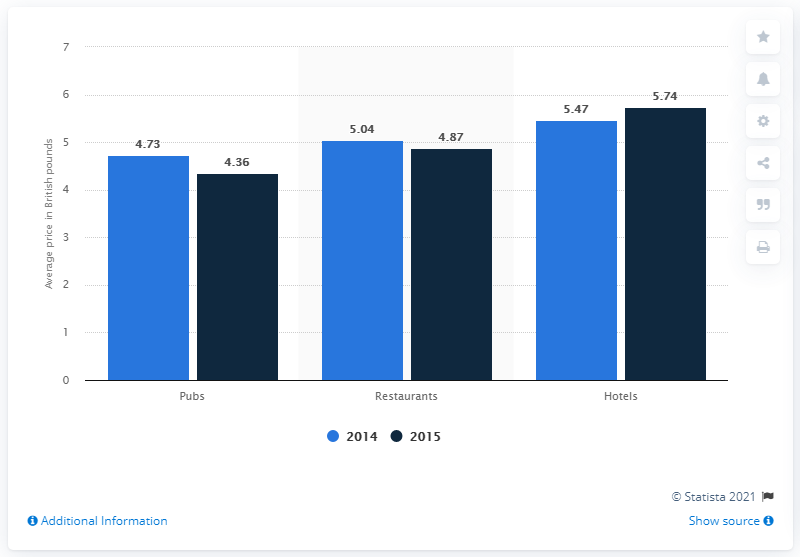Give some essential details in this illustration. The difference between the highest and lowest dark blue bar is 1.38... The average price of desserts when eating in pubs and hotels in 2014 was around 5.1 dollars. 